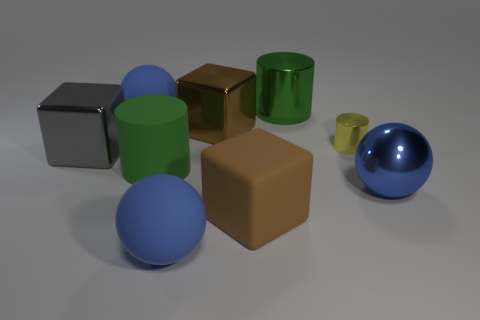What number of small yellow shiny objects are the same shape as the brown rubber object?
Offer a very short reply. 0. What is the size of the cube that is the same material as the large gray thing?
Offer a very short reply. Large. There is a large cylinder that is behind the big green cylinder that is in front of the large green metal thing; is there a large shiny block that is on the right side of it?
Provide a short and direct response. No. There is a brown cube behind the brown rubber thing; is it the same size as the yellow metal object?
Provide a short and direct response. No. What number of matte cubes have the same size as the yellow cylinder?
Offer a very short reply. 0. The shiny thing that is the same color as the large rubber cube is what size?
Your response must be concise. Large. Is the color of the matte cube the same as the tiny cylinder?
Provide a short and direct response. No. The large brown rubber object is what shape?
Offer a very short reply. Cube. Are there any rubber cylinders that have the same color as the big matte cube?
Give a very brief answer. No. Is the number of yellow shiny cylinders to the left of the big green rubber cylinder greater than the number of big green rubber objects?
Offer a very short reply. No. 